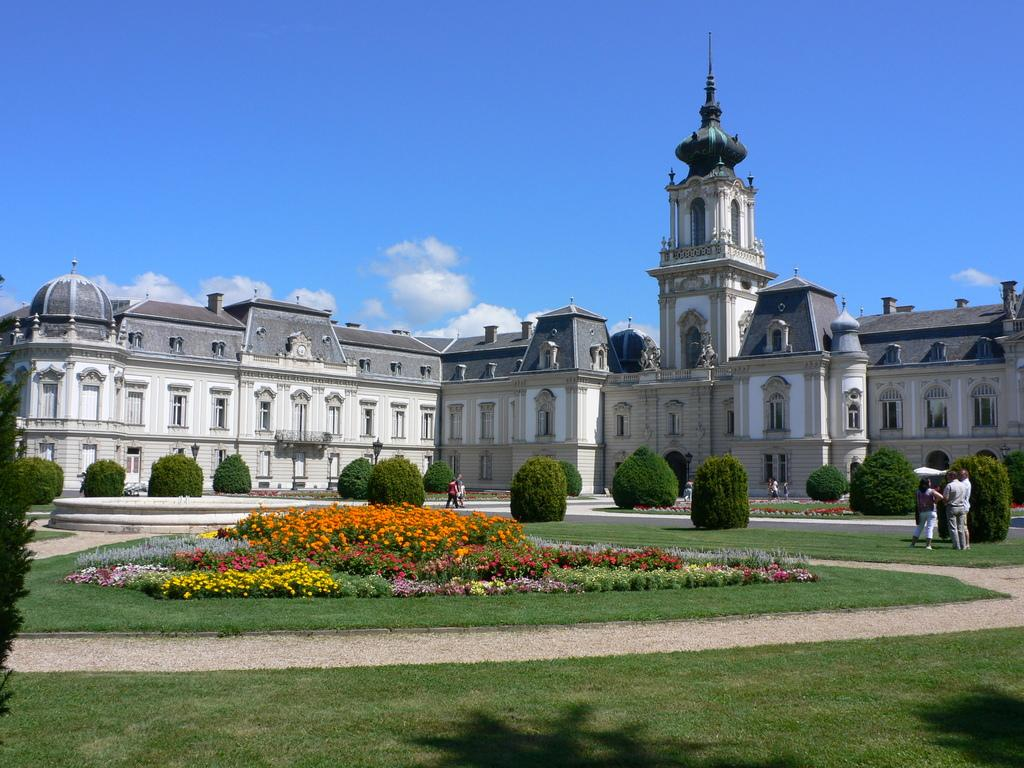What can be seen in the sky in the image? The sky is visible in the image, and there are clouds present. What type of structure is in the image? There is at least one building in the image, and it has windows. What type of vegetation is present in the image? There are trees, plants, flowers, and grass in the image. Are there any living beings in the image? Yes, there are people in the image. What year is depicted in the image? The image does not depict a specific year; it is a general scene with a building, sky, clouds, and people. Can you see any rays of light in the image? There is no mention of rays of light in the provided facts, so we cannot determine if they are present in the image. 